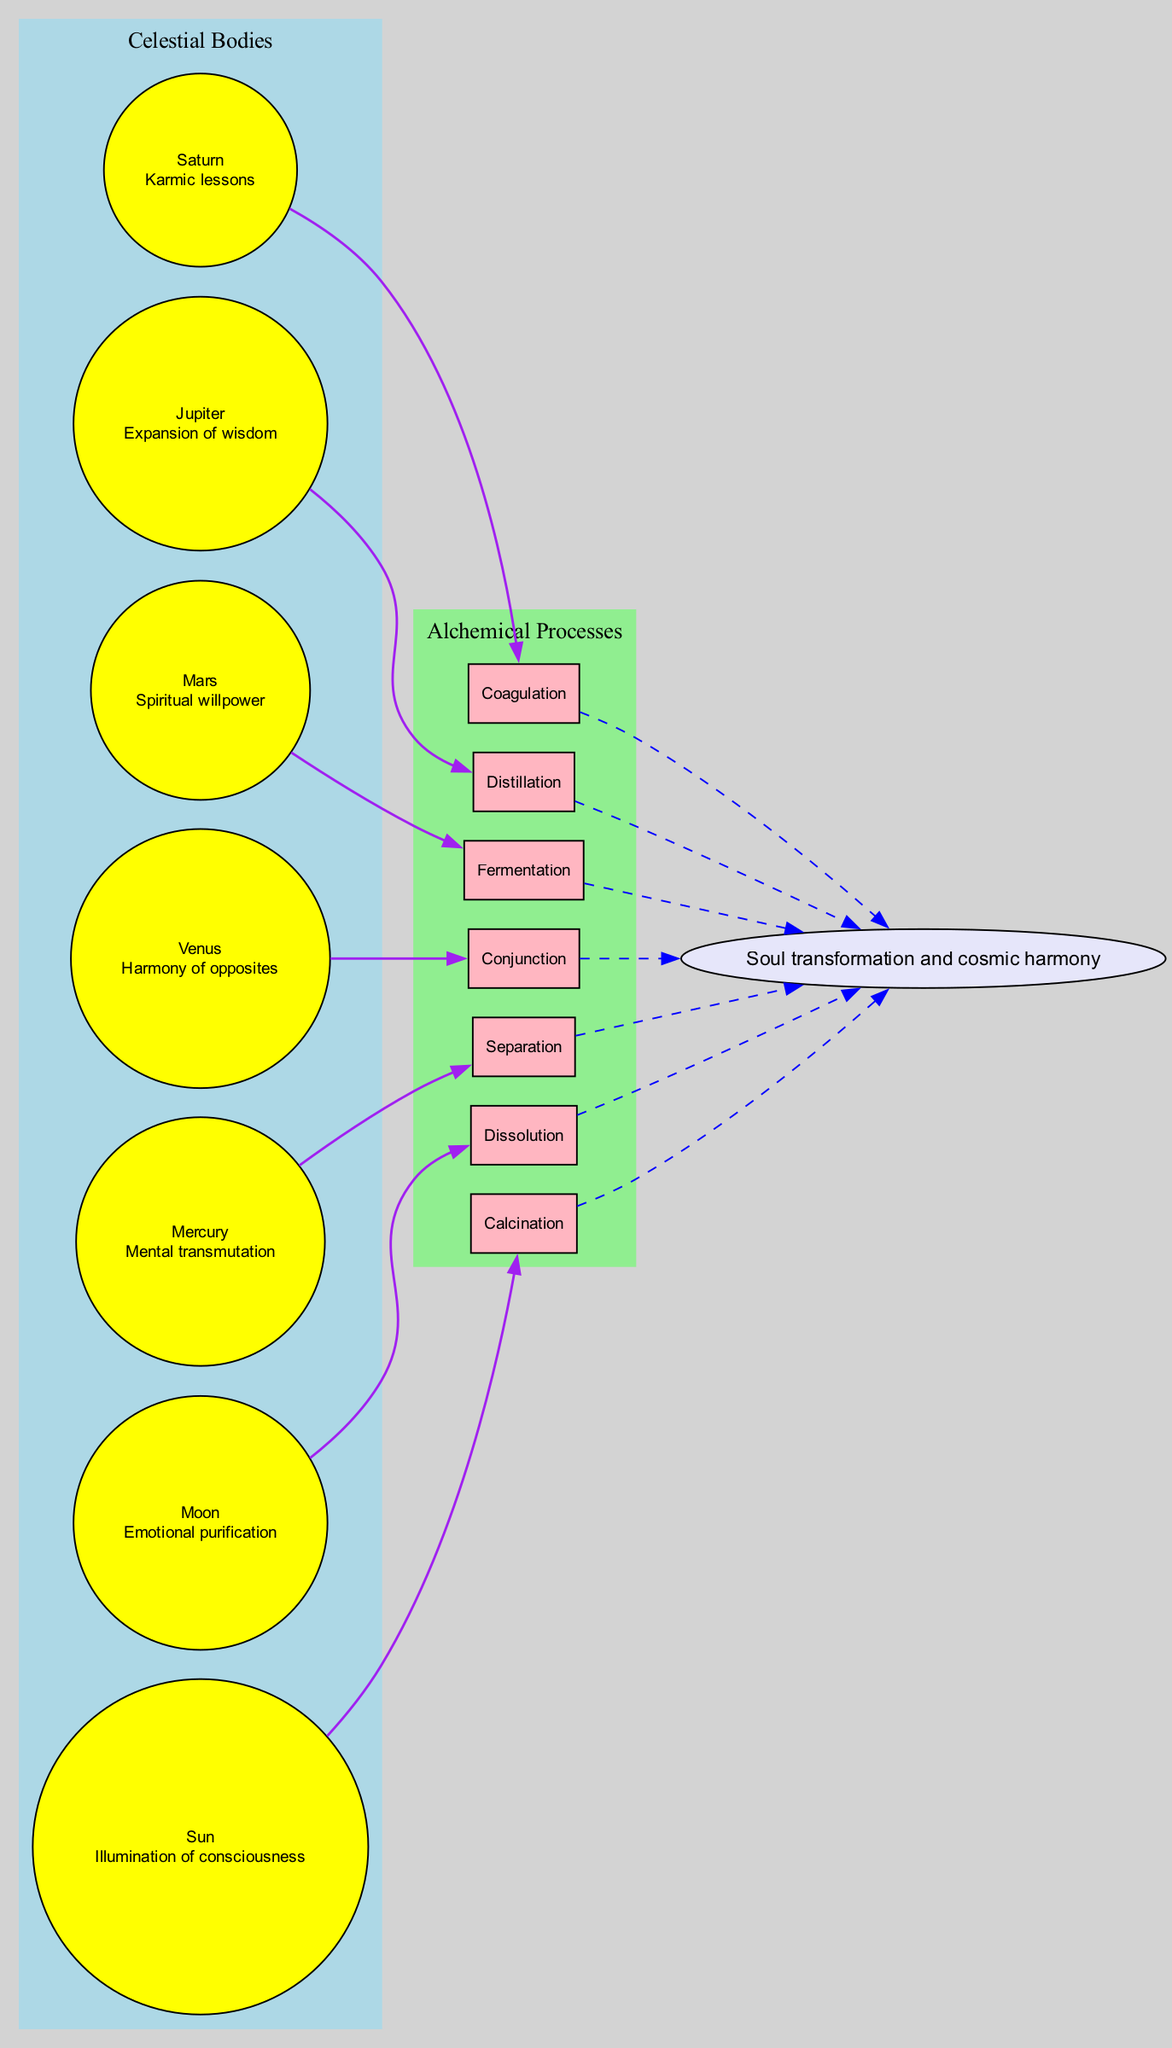What is the influence of the Sun? The diagram lists each celestial body alongside its influence. The Sun is specifically associated with the "Illumination of consciousness."
Answer: Illumination of consciousness Which alchemical process is influenced by Jupiter? Each alchemical process is paired with a celestial body that influences it. Jupiter is linked to the "Distillation" process.
Answer: Distillation How many celestial bodies are represented in the diagram? By counting the nodes in the celestial bodies subgraph, we find that there are a total of seven celestial bodies listed in the diagram.
Answer: 7 What alchemical process is linked to the planet Mercury? The diagram shows that the alchemical process "Separation" is directly influenced by the planet Mercury, as indicated by the connecting edges.
Answer: Separation What is the spiritual outcome depicted in the diagram? The diagram concludes with a node describing the overall spiritual outcome, which is "Soul transformation and cosmic harmony."
Answer: Soul transformation and cosmic harmony Which celestial body represents emotional purification? Referring to the celestial bodies and their influences, the Moon is specifically identified with the influence of "Emotional purification."
Answer: Moon Which alchemical process has a connection to Saturn? By observing the links in the diagram, Saturn relates directly to the alchemical process of "Coagulation," making it clear which process is associated with this celestial body.
Answer: Coagulation How many alchemical processes are influenced by celestial bodies? The diagram shows a direct connection between celestial bodies and seven specified alchemical processes, indicating that all celestial bodies influence an alchemical process.
Answer: 7 What influence does Mars have according to the diagram? The influence associated with Mars is explicitly described as "Spiritual willpower" in the celestial body section of the diagram.
Answer: Spiritual willpower 